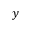<formula> <loc_0><loc_0><loc_500><loc_500>y</formula> 